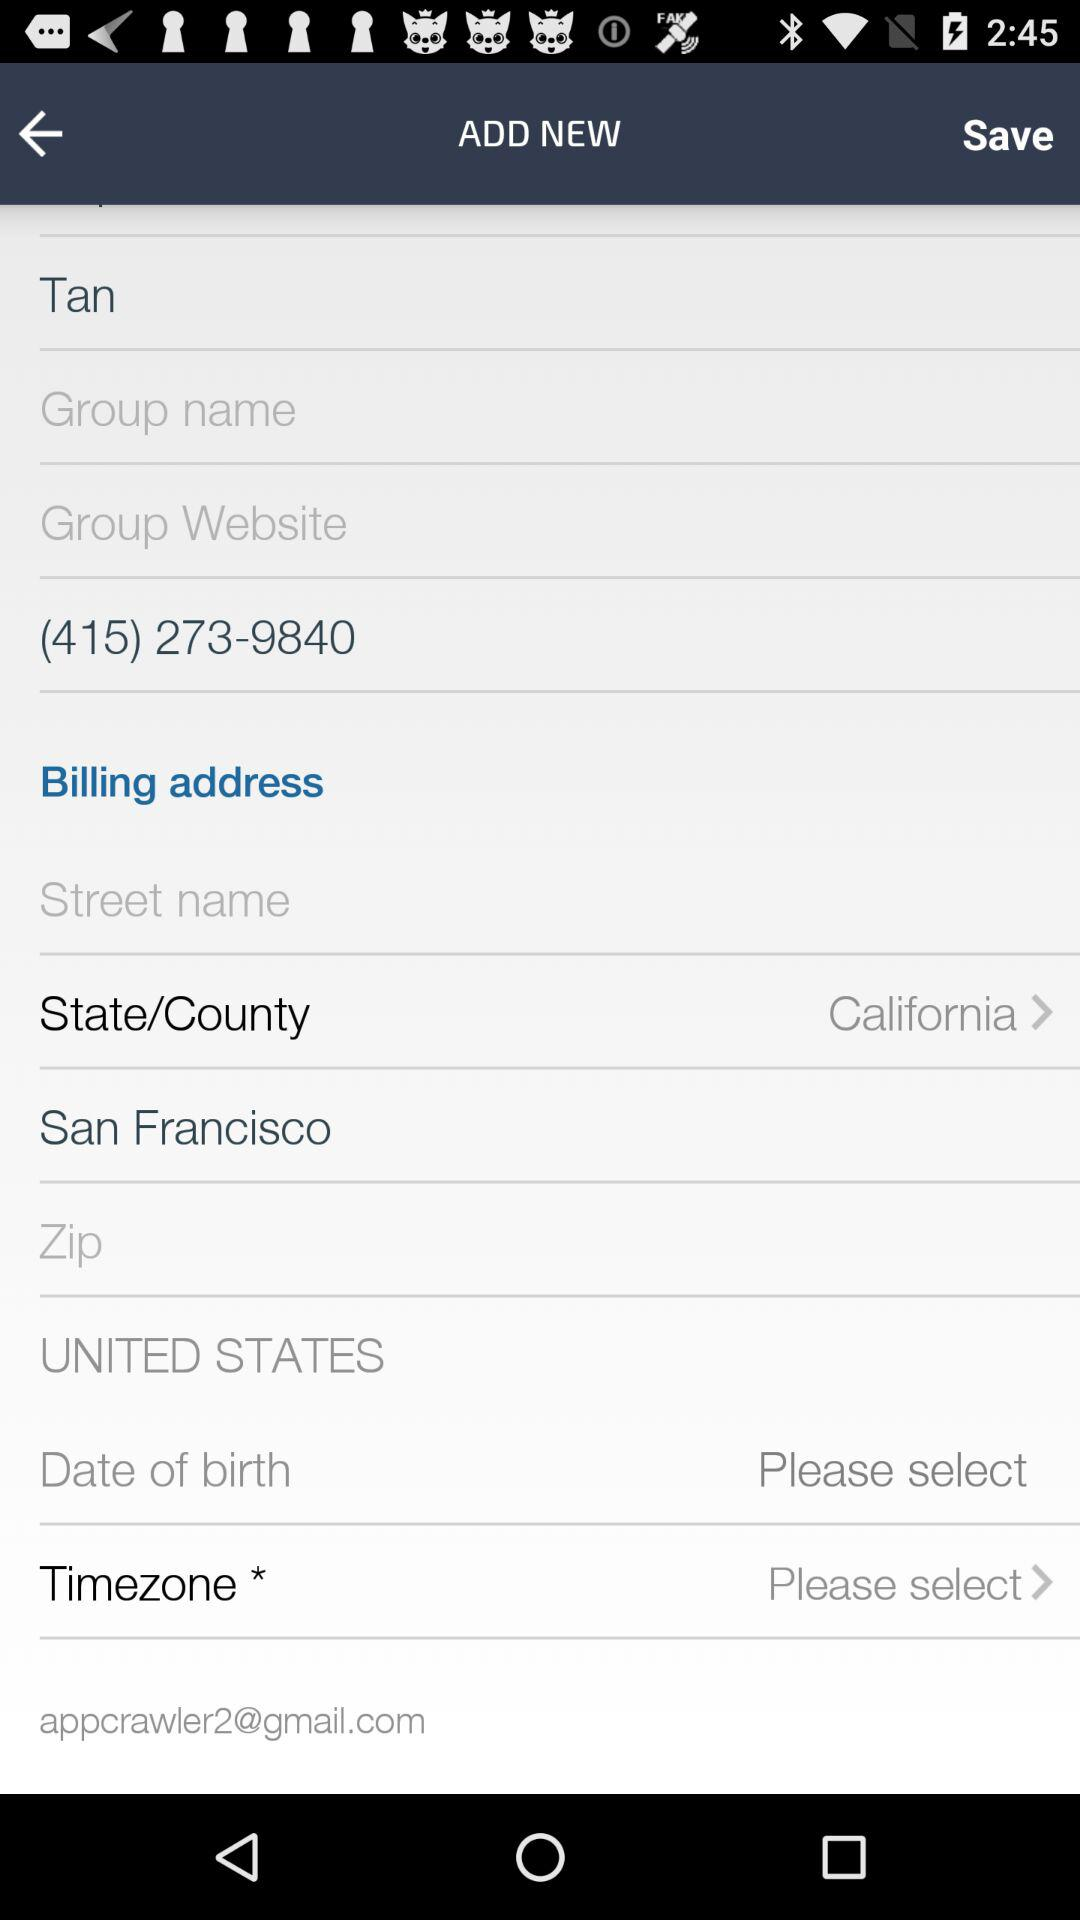What is the user name? The user name is Tan. 